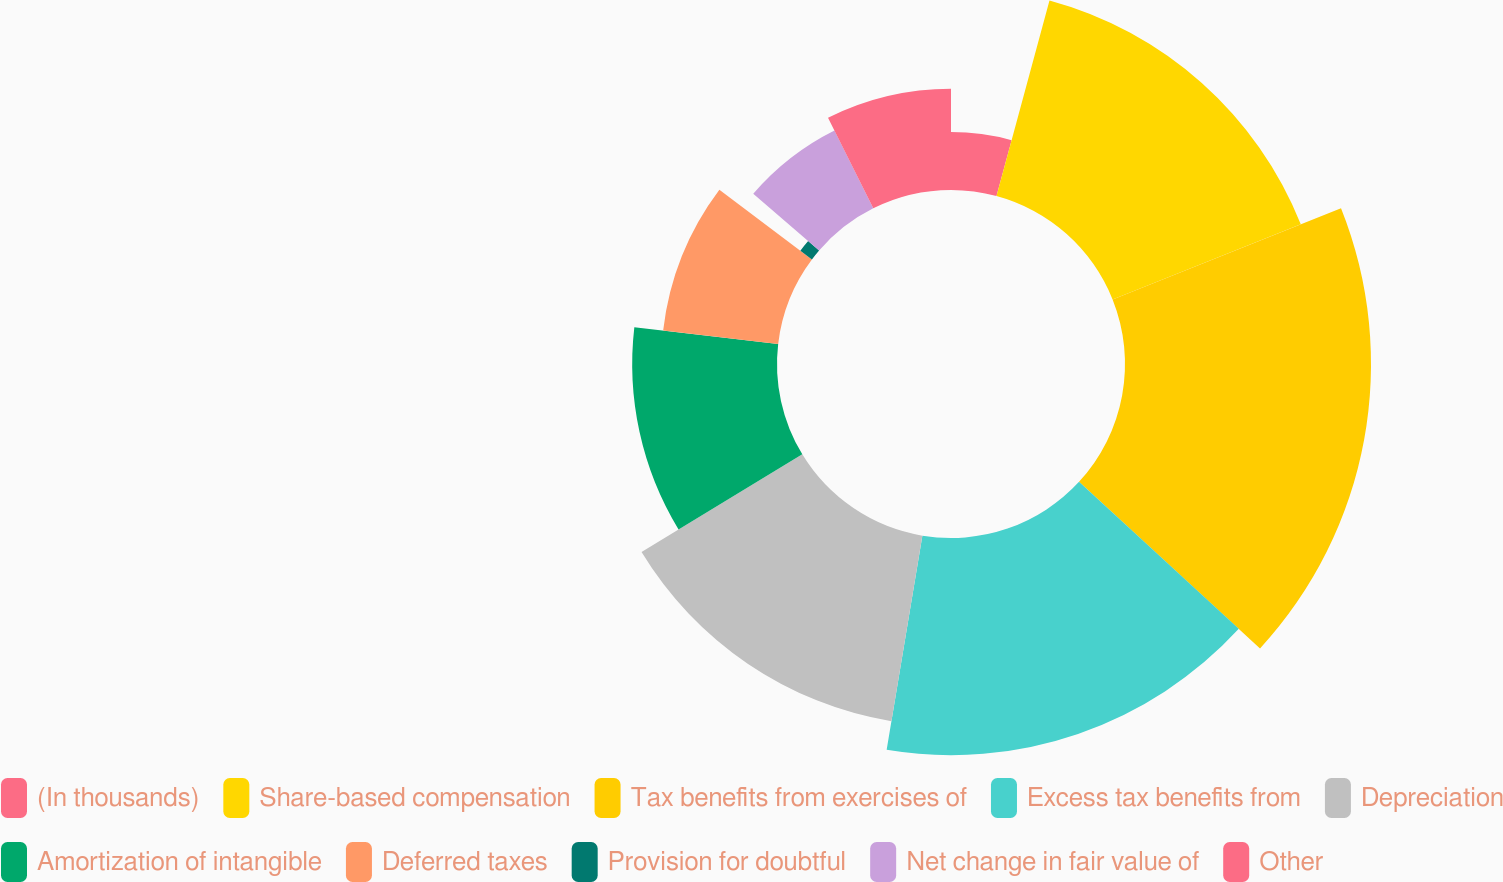Convert chart to OTSL. <chart><loc_0><loc_0><loc_500><loc_500><pie_chart><fcel>(In thousands)<fcel>Share-based compensation<fcel>Tax benefits from exercises of<fcel>Excess tax benefits from<fcel>Depreciation<fcel>Amortization of intangible<fcel>Deferred taxes<fcel>Provision for doubtful<fcel>Net change in fair value of<fcel>Other<nl><fcel>4.21%<fcel>14.74%<fcel>17.89%<fcel>15.79%<fcel>13.68%<fcel>10.53%<fcel>8.42%<fcel>1.05%<fcel>6.32%<fcel>7.37%<nl></chart> 